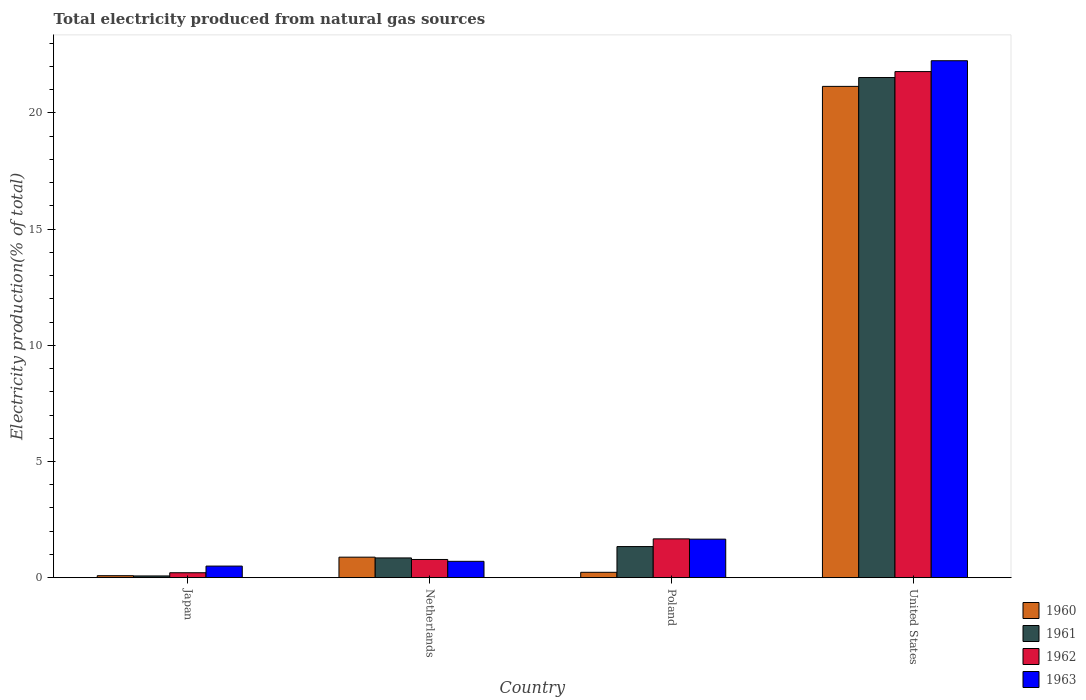How many different coloured bars are there?
Your answer should be very brief. 4. How many groups of bars are there?
Offer a terse response. 4. Are the number of bars per tick equal to the number of legend labels?
Your answer should be compact. Yes. Are the number of bars on each tick of the X-axis equal?
Ensure brevity in your answer.  Yes. How many bars are there on the 1st tick from the left?
Give a very brief answer. 4. How many bars are there on the 2nd tick from the right?
Give a very brief answer. 4. In how many cases, is the number of bars for a given country not equal to the number of legend labels?
Offer a very short reply. 0. What is the total electricity produced in 1961 in United States?
Provide a short and direct response. 21.52. Across all countries, what is the maximum total electricity produced in 1962?
Provide a succinct answer. 21.78. Across all countries, what is the minimum total electricity produced in 1961?
Keep it short and to the point. 0.08. In which country was the total electricity produced in 1960 minimum?
Make the answer very short. Japan. What is the total total electricity produced in 1961 in the graph?
Keep it short and to the point. 23.79. What is the difference between the total electricity produced in 1962 in Netherlands and that in Poland?
Your answer should be compact. -0.89. What is the difference between the total electricity produced in 1962 in Netherlands and the total electricity produced in 1960 in United States?
Your response must be concise. -20.36. What is the average total electricity produced in 1962 per country?
Provide a short and direct response. 6.11. What is the difference between the total electricity produced of/in 1962 and total electricity produced of/in 1961 in Japan?
Give a very brief answer. 0.14. In how many countries, is the total electricity produced in 1961 greater than 9 %?
Your response must be concise. 1. What is the ratio of the total electricity produced in 1960 in Japan to that in Poland?
Provide a short and direct response. 0.37. Is the difference between the total electricity produced in 1962 in Japan and Poland greater than the difference between the total electricity produced in 1961 in Japan and Poland?
Your answer should be very brief. No. What is the difference between the highest and the second highest total electricity produced in 1960?
Provide a succinct answer. 0.65. What is the difference between the highest and the lowest total electricity produced in 1963?
Give a very brief answer. 21.74. In how many countries, is the total electricity produced in 1963 greater than the average total electricity produced in 1963 taken over all countries?
Make the answer very short. 1. Is the sum of the total electricity produced in 1962 in Japan and Poland greater than the maximum total electricity produced in 1960 across all countries?
Ensure brevity in your answer.  No. What does the 3rd bar from the right in Poland represents?
Keep it short and to the point. 1961. How many bars are there?
Provide a succinct answer. 16. Are all the bars in the graph horizontal?
Ensure brevity in your answer.  No. How many countries are there in the graph?
Provide a succinct answer. 4. What is the difference between two consecutive major ticks on the Y-axis?
Offer a terse response. 5. Are the values on the major ticks of Y-axis written in scientific E-notation?
Make the answer very short. No. Where does the legend appear in the graph?
Keep it short and to the point. Bottom right. How are the legend labels stacked?
Give a very brief answer. Vertical. What is the title of the graph?
Provide a succinct answer. Total electricity produced from natural gas sources. Does "2008" appear as one of the legend labels in the graph?
Give a very brief answer. No. What is the label or title of the Y-axis?
Your answer should be compact. Electricity production(% of total). What is the Electricity production(% of total) in 1960 in Japan?
Your answer should be compact. 0.09. What is the Electricity production(% of total) of 1961 in Japan?
Provide a succinct answer. 0.08. What is the Electricity production(% of total) in 1962 in Japan?
Offer a terse response. 0.21. What is the Electricity production(% of total) of 1963 in Japan?
Offer a very short reply. 0.5. What is the Electricity production(% of total) in 1960 in Netherlands?
Your response must be concise. 0.88. What is the Electricity production(% of total) in 1961 in Netherlands?
Your response must be concise. 0.85. What is the Electricity production(% of total) in 1962 in Netherlands?
Your answer should be compact. 0.78. What is the Electricity production(% of total) of 1963 in Netherlands?
Offer a terse response. 0.71. What is the Electricity production(% of total) of 1960 in Poland?
Your answer should be very brief. 0.23. What is the Electricity production(% of total) in 1961 in Poland?
Ensure brevity in your answer.  1.34. What is the Electricity production(% of total) of 1962 in Poland?
Provide a succinct answer. 1.67. What is the Electricity production(% of total) in 1963 in Poland?
Provide a succinct answer. 1.66. What is the Electricity production(% of total) of 1960 in United States?
Ensure brevity in your answer.  21.14. What is the Electricity production(% of total) in 1961 in United States?
Your answer should be compact. 21.52. What is the Electricity production(% of total) of 1962 in United States?
Give a very brief answer. 21.78. What is the Electricity production(% of total) in 1963 in United States?
Offer a very short reply. 22.24. Across all countries, what is the maximum Electricity production(% of total) in 1960?
Your answer should be very brief. 21.14. Across all countries, what is the maximum Electricity production(% of total) of 1961?
Offer a terse response. 21.52. Across all countries, what is the maximum Electricity production(% of total) in 1962?
Ensure brevity in your answer.  21.78. Across all countries, what is the maximum Electricity production(% of total) of 1963?
Your answer should be compact. 22.24. Across all countries, what is the minimum Electricity production(% of total) of 1960?
Offer a very short reply. 0.09. Across all countries, what is the minimum Electricity production(% of total) of 1961?
Keep it short and to the point. 0.08. Across all countries, what is the minimum Electricity production(% of total) of 1962?
Provide a succinct answer. 0.21. Across all countries, what is the minimum Electricity production(% of total) in 1963?
Your answer should be very brief. 0.5. What is the total Electricity production(% of total) of 1960 in the graph?
Make the answer very short. 22.34. What is the total Electricity production(% of total) of 1961 in the graph?
Provide a short and direct response. 23.79. What is the total Electricity production(% of total) of 1962 in the graph?
Provide a succinct answer. 24.45. What is the total Electricity production(% of total) of 1963 in the graph?
Your answer should be very brief. 25.11. What is the difference between the Electricity production(% of total) in 1960 in Japan and that in Netherlands?
Offer a terse response. -0.8. What is the difference between the Electricity production(% of total) of 1961 in Japan and that in Netherlands?
Give a very brief answer. -0.78. What is the difference between the Electricity production(% of total) in 1962 in Japan and that in Netherlands?
Your response must be concise. -0.57. What is the difference between the Electricity production(% of total) of 1963 in Japan and that in Netherlands?
Your answer should be very brief. -0.21. What is the difference between the Electricity production(% of total) in 1960 in Japan and that in Poland?
Ensure brevity in your answer.  -0.15. What is the difference between the Electricity production(% of total) in 1961 in Japan and that in Poland?
Ensure brevity in your answer.  -1.26. What is the difference between the Electricity production(% of total) of 1962 in Japan and that in Poland?
Offer a terse response. -1.46. What is the difference between the Electricity production(% of total) in 1963 in Japan and that in Poland?
Ensure brevity in your answer.  -1.16. What is the difference between the Electricity production(% of total) in 1960 in Japan and that in United States?
Keep it short and to the point. -21.05. What is the difference between the Electricity production(% of total) in 1961 in Japan and that in United States?
Your answer should be compact. -21.45. What is the difference between the Electricity production(% of total) in 1962 in Japan and that in United States?
Offer a very short reply. -21.56. What is the difference between the Electricity production(% of total) of 1963 in Japan and that in United States?
Provide a short and direct response. -21.74. What is the difference between the Electricity production(% of total) of 1960 in Netherlands and that in Poland?
Your answer should be compact. 0.65. What is the difference between the Electricity production(% of total) in 1961 in Netherlands and that in Poland?
Provide a short and direct response. -0.49. What is the difference between the Electricity production(% of total) in 1962 in Netherlands and that in Poland?
Your response must be concise. -0.89. What is the difference between the Electricity production(% of total) in 1963 in Netherlands and that in Poland?
Provide a succinct answer. -0.95. What is the difference between the Electricity production(% of total) in 1960 in Netherlands and that in United States?
Give a very brief answer. -20.26. What is the difference between the Electricity production(% of total) of 1961 in Netherlands and that in United States?
Offer a terse response. -20.67. What is the difference between the Electricity production(% of total) of 1962 in Netherlands and that in United States?
Make the answer very short. -20.99. What is the difference between the Electricity production(% of total) in 1963 in Netherlands and that in United States?
Ensure brevity in your answer.  -21.54. What is the difference between the Electricity production(% of total) of 1960 in Poland and that in United States?
Offer a terse response. -20.91. What is the difference between the Electricity production(% of total) of 1961 in Poland and that in United States?
Offer a terse response. -20.18. What is the difference between the Electricity production(% of total) in 1962 in Poland and that in United States?
Your answer should be very brief. -20.11. What is the difference between the Electricity production(% of total) in 1963 in Poland and that in United States?
Ensure brevity in your answer.  -20.59. What is the difference between the Electricity production(% of total) in 1960 in Japan and the Electricity production(% of total) in 1961 in Netherlands?
Keep it short and to the point. -0.76. What is the difference between the Electricity production(% of total) of 1960 in Japan and the Electricity production(% of total) of 1962 in Netherlands?
Your answer should be compact. -0.7. What is the difference between the Electricity production(% of total) of 1960 in Japan and the Electricity production(% of total) of 1963 in Netherlands?
Your answer should be compact. -0.62. What is the difference between the Electricity production(% of total) in 1961 in Japan and the Electricity production(% of total) in 1962 in Netherlands?
Provide a short and direct response. -0.71. What is the difference between the Electricity production(% of total) in 1961 in Japan and the Electricity production(% of total) in 1963 in Netherlands?
Your answer should be very brief. -0.63. What is the difference between the Electricity production(% of total) in 1962 in Japan and the Electricity production(% of total) in 1963 in Netherlands?
Offer a very short reply. -0.49. What is the difference between the Electricity production(% of total) of 1960 in Japan and the Electricity production(% of total) of 1961 in Poland?
Provide a short and direct response. -1.25. What is the difference between the Electricity production(% of total) of 1960 in Japan and the Electricity production(% of total) of 1962 in Poland?
Provide a short and direct response. -1.58. What is the difference between the Electricity production(% of total) in 1960 in Japan and the Electricity production(% of total) in 1963 in Poland?
Provide a short and direct response. -1.57. What is the difference between the Electricity production(% of total) of 1961 in Japan and the Electricity production(% of total) of 1962 in Poland?
Your answer should be compact. -1.6. What is the difference between the Electricity production(% of total) of 1961 in Japan and the Electricity production(% of total) of 1963 in Poland?
Your answer should be compact. -1.58. What is the difference between the Electricity production(% of total) in 1962 in Japan and the Electricity production(% of total) in 1963 in Poland?
Give a very brief answer. -1.45. What is the difference between the Electricity production(% of total) of 1960 in Japan and the Electricity production(% of total) of 1961 in United States?
Give a very brief answer. -21.43. What is the difference between the Electricity production(% of total) of 1960 in Japan and the Electricity production(% of total) of 1962 in United States?
Your answer should be very brief. -21.69. What is the difference between the Electricity production(% of total) in 1960 in Japan and the Electricity production(% of total) in 1963 in United States?
Your answer should be compact. -22.16. What is the difference between the Electricity production(% of total) in 1961 in Japan and the Electricity production(% of total) in 1962 in United States?
Make the answer very short. -21.7. What is the difference between the Electricity production(% of total) in 1961 in Japan and the Electricity production(% of total) in 1963 in United States?
Provide a succinct answer. -22.17. What is the difference between the Electricity production(% of total) of 1962 in Japan and the Electricity production(% of total) of 1963 in United States?
Provide a short and direct response. -22.03. What is the difference between the Electricity production(% of total) in 1960 in Netherlands and the Electricity production(% of total) in 1961 in Poland?
Offer a terse response. -0.46. What is the difference between the Electricity production(% of total) of 1960 in Netherlands and the Electricity production(% of total) of 1962 in Poland?
Ensure brevity in your answer.  -0.79. What is the difference between the Electricity production(% of total) of 1960 in Netherlands and the Electricity production(% of total) of 1963 in Poland?
Provide a succinct answer. -0.78. What is the difference between the Electricity production(% of total) of 1961 in Netherlands and the Electricity production(% of total) of 1962 in Poland?
Give a very brief answer. -0.82. What is the difference between the Electricity production(% of total) of 1961 in Netherlands and the Electricity production(% of total) of 1963 in Poland?
Your response must be concise. -0.81. What is the difference between the Electricity production(% of total) in 1962 in Netherlands and the Electricity production(% of total) in 1963 in Poland?
Offer a very short reply. -0.88. What is the difference between the Electricity production(% of total) of 1960 in Netherlands and the Electricity production(% of total) of 1961 in United States?
Provide a succinct answer. -20.64. What is the difference between the Electricity production(% of total) in 1960 in Netherlands and the Electricity production(% of total) in 1962 in United States?
Provide a short and direct response. -20.89. What is the difference between the Electricity production(% of total) of 1960 in Netherlands and the Electricity production(% of total) of 1963 in United States?
Make the answer very short. -21.36. What is the difference between the Electricity production(% of total) in 1961 in Netherlands and the Electricity production(% of total) in 1962 in United States?
Make the answer very short. -20.93. What is the difference between the Electricity production(% of total) of 1961 in Netherlands and the Electricity production(% of total) of 1963 in United States?
Give a very brief answer. -21.39. What is the difference between the Electricity production(% of total) in 1962 in Netherlands and the Electricity production(% of total) in 1963 in United States?
Give a very brief answer. -21.46. What is the difference between the Electricity production(% of total) of 1960 in Poland and the Electricity production(% of total) of 1961 in United States?
Offer a terse response. -21.29. What is the difference between the Electricity production(% of total) in 1960 in Poland and the Electricity production(% of total) in 1962 in United States?
Keep it short and to the point. -21.55. What is the difference between the Electricity production(% of total) in 1960 in Poland and the Electricity production(% of total) in 1963 in United States?
Provide a succinct answer. -22.01. What is the difference between the Electricity production(% of total) of 1961 in Poland and the Electricity production(% of total) of 1962 in United States?
Provide a succinct answer. -20.44. What is the difference between the Electricity production(% of total) of 1961 in Poland and the Electricity production(% of total) of 1963 in United States?
Provide a short and direct response. -20.91. What is the difference between the Electricity production(% of total) of 1962 in Poland and the Electricity production(% of total) of 1963 in United States?
Offer a very short reply. -20.57. What is the average Electricity production(% of total) of 1960 per country?
Ensure brevity in your answer.  5.59. What is the average Electricity production(% of total) in 1961 per country?
Your response must be concise. 5.95. What is the average Electricity production(% of total) of 1962 per country?
Give a very brief answer. 6.11. What is the average Electricity production(% of total) in 1963 per country?
Your answer should be very brief. 6.28. What is the difference between the Electricity production(% of total) of 1960 and Electricity production(% of total) of 1961 in Japan?
Offer a very short reply. 0.01. What is the difference between the Electricity production(% of total) of 1960 and Electricity production(% of total) of 1962 in Japan?
Keep it short and to the point. -0.13. What is the difference between the Electricity production(% of total) in 1960 and Electricity production(% of total) in 1963 in Japan?
Offer a terse response. -0.41. What is the difference between the Electricity production(% of total) of 1961 and Electricity production(% of total) of 1962 in Japan?
Your answer should be compact. -0.14. What is the difference between the Electricity production(% of total) in 1961 and Electricity production(% of total) in 1963 in Japan?
Keep it short and to the point. -0.42. What is the difference between the Electricity production(% of total) of 1962 and Electricity production(% of total) of 1963 in Japan?
Offer a terse response. -0.29. What is the difference between the Electricity production(% of total) in 1960 and Electricity production(% of total) in 1961 in Netherlands?
Keep it short and to the point. 0.03. What is the difference between the Electricity production(% of total) in 1960 and Electricity production(% of total) in 1962 in Netherlands?
Your response must be concise. 0.1. What is the difference between the Electricity production(% of total) in 1960 and Electricity production(% of total) in 1963 in Netherlands?
Give a very brief answer. 0.18. What is the difference between the Electricity production(% of total) of 1961 and Electricity production(% of total) of 1962 in Netherlands?
Offer a terse response. 0.07. What is the difference between the Electricity production(% of total) in 1961 and Electricity production(% of total) in 1963 in Netherlands?
Give a very brief answer. 0.15. What is the difference between the Electricity production(% of total) of 1962 and Electricity production(% of total) of 1963 in Netherlands?
Offer a terse response. 0.08. What is the difference between the Electricity production(% of total) of 1960 and Electricity production(% of total) of 1961 in Poland?
Your response must be concise. -1.11. What is the difference between the Electricity production(% of total) in 1960 and Electricity production(% of total) in 1962 in Poland?
Make the answer very short. -1.44. What is the difference between the Electricity production(% of total) of 1960 and Electricity production(% of total) of 1963 in Poland?
Ensure brevity in your answer.  -1.43. What is the difference between the Electricity production(% of total) of 1961 and Electricity production(% of total) of 1962 in Poland?
Provide a short and direct response. -0.33. What is the difference between the Electricity production(% of total) of 1961 and Electricity production(% of total) of 1963 in Poland?
Make the answer very short. -0.32. What is the difference between the Electricity production(% of total) of 1962 and Electricity production(% of total) of 1963 in Poland?
Offer a very short reply. 0.01. What is the difference between the Electricity production(% of total) of 1960 and Electricity production(% of total) of 1961 in United States?
Offer a terse response. -0.38. What is the difference between the Electricity production(% of total) in 1960 and Electricity production(% of total) in 1962 in United States?
Your answer should be compact. -0.64. What is the difference between the Electricity production(% of total) in 1960 and Electricity production(% of total) in 1963 in United States?
Provide a short and direct response. -1.1. What is the difference between the Electricity production(% of total) of 1961 and Electricity production(% of total) of 1962 in United States?
Provide a succinct answer. -0.26. What is the difference between the Electricity production(% of total) in 1961 and Electricity production(% of total) in 1963 in United States?
Provide a succinct answer. -0.72. What is the difference between the Electricity production(% of total) in 1962 and Electricity production(% of total) in 1963 in United States?
Give a very brief answer. -0.47. What is the ratio of the Electricity production(% of total) of 1960 in Japan to that in Netherlands?
Your answer should be very brief. 0.1. What is the ratio of the Electricity production(% of total) of 1961 in Japan to that in Netherlands?
Offer a terse response. 0.09. What is the ratio of the Electricity production(% of total) of 1962 in Japan to that in Netherlands?
Provide a short and direct response. 0.27. What is the ratio of the Electricity production(% of total) in 1963 in Japan to that in Netherlands?
Provide a short and direct response. 0.71. What is the ratio of the Electricity production(% of total) of 1960 in Japan to that in Poland?
Your response must be concise. 0.37. What is the ratio of the Electricity production(% of total) in 1961 in Japan to that in Poland?
Give a very brief answer. 0.06. What is the ratio of the Electricity production(% of total) in 1962 in Japan to that in Poland?
Make the answer very short. 0.13. What is the ratio of the Electricity production(% of total) in 1963 in Japan to that in Poland?
Offer a very short reply. 0.3. What is the ratio of the Electricity production(% of total) of 1960 in Japan to that in United States?
Ensure brevity in your answer.  0. What is the ratio of the Electricity production(% of total) in 1961 in Japan to that in United States?
Keep it short and to the point. 0. What is the ratio of the Electricity production(% of total) of 1962 in Japan to that in United States?
Ensure brevity in your answer.  0.01. What is the ratio of the Electricity production(% of total) of 1963 in Japan to that in United States?
Your answer should be compact. 0.02. What is the ratio of the Electricity production(% of total) of 1960 in Netherlands to that in Poland?
Make the answer very short. 3.81. What is the ratio of the Electricity production(% of total) in 1961 in Netherlands to that in Poland?
Keep it short and to the point. 0.64. What is the ratio of the Electricity production(% of total) of 1962 in Netherlands to that in Poland?
Give a very brief answer. 0.47. What is the ratio of the Electricity production(% of total) in 1963 in Netherlands to that in Poland?
Give a very brief answer. 0.42. What is the ratio of the Electricity production(% of total) of 1960 in Netherlands to that in United States?
Keep it short and to the point. 0.04. What is the ratio of the Electricity production(% of total) in 1961 in Netherlands to that in United States?
Keep it short and to the point. 0.04. What is the ratio of the Electricity production(% of total) in 1962 in Netherlands to that in United States?
Offer a very short reply. 0.04. What is the ratio of the Electricity production(% of total) in 1963 in Netherlands to that in United States?
Provide a short and direct response. 0.03. What is the ratio of the Electricity production(% of total) of 1960 in Poland to that in United States?
Make the answer very short. 0.01. What is the ratio of the Electricity production(% of total) in 1961 in Poland to that in United States?
Provide a short and direct response. 0.06. What is the ratio of the Electricity production(% of total) in 1962 in Poland to that in United States?
Give a very brief answer. 0.08. What is the ratio of the Electricity production(% of total) of 1963 in Poland to that in United States?
Your answer should be very brief. 0.07. What is the difference between the highest and the second highest Electricity production(% of total) of 1960?
Ensure brevity in your answer.  20.26. What is the difference between the highest and the second highest Electricity production(% of total) in 1961?
Give a very brief answer. 20.18. What is the difference between the highest and the second highest Electricity production(% of total) of 1962?
Your answer should be compact. 20.11. What is the difference between the highest and the second highest Electricity production(% of total) in 1963?
Keep it short and to the point. 20.59. What is the difference between the highest and the lowest Electricity production(% of total) in 1960?
Provide a succinct answer. 21.05. What is the difference between the highest and the lowest Electricity production(% of total) of 1961?
Provide a short and direct response. 21.45. What is the difference between the highest and the lowest Electricity production(% of total) of 1962?
Give a very brief answer. 21.56. What is the difference between the highest and the lowest Electricity production(% of total) in 1963?
Give a very brief answer. 21.74. 